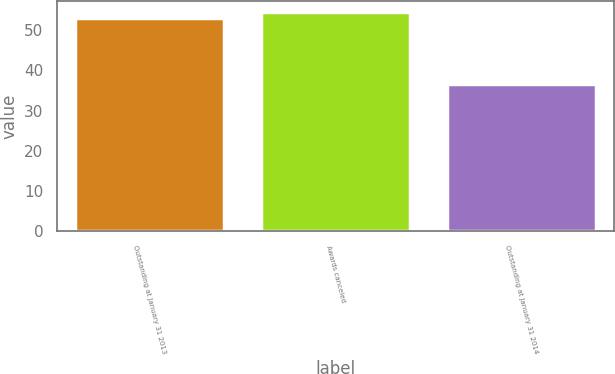Convert chart. <chart><loc_0><loc_0><loc_500><loc_500><bar_chart><fcel>Outstanding at January 31 2013<fcel>Awards canceled<fcel>Outstanding at January 31 2014<nl><fcel>52.96<fcel>54.61<fcel>36.66<nl></chart> 